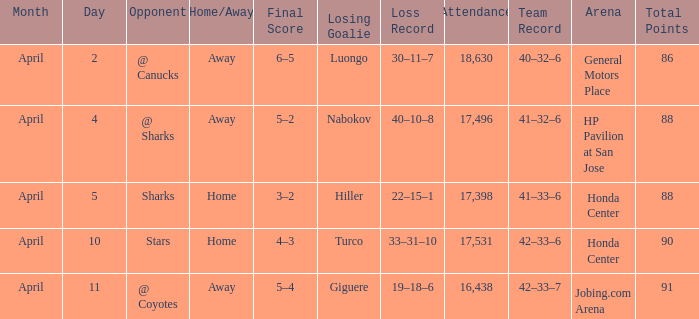On what date was the Record 41–32–6? April 4. 